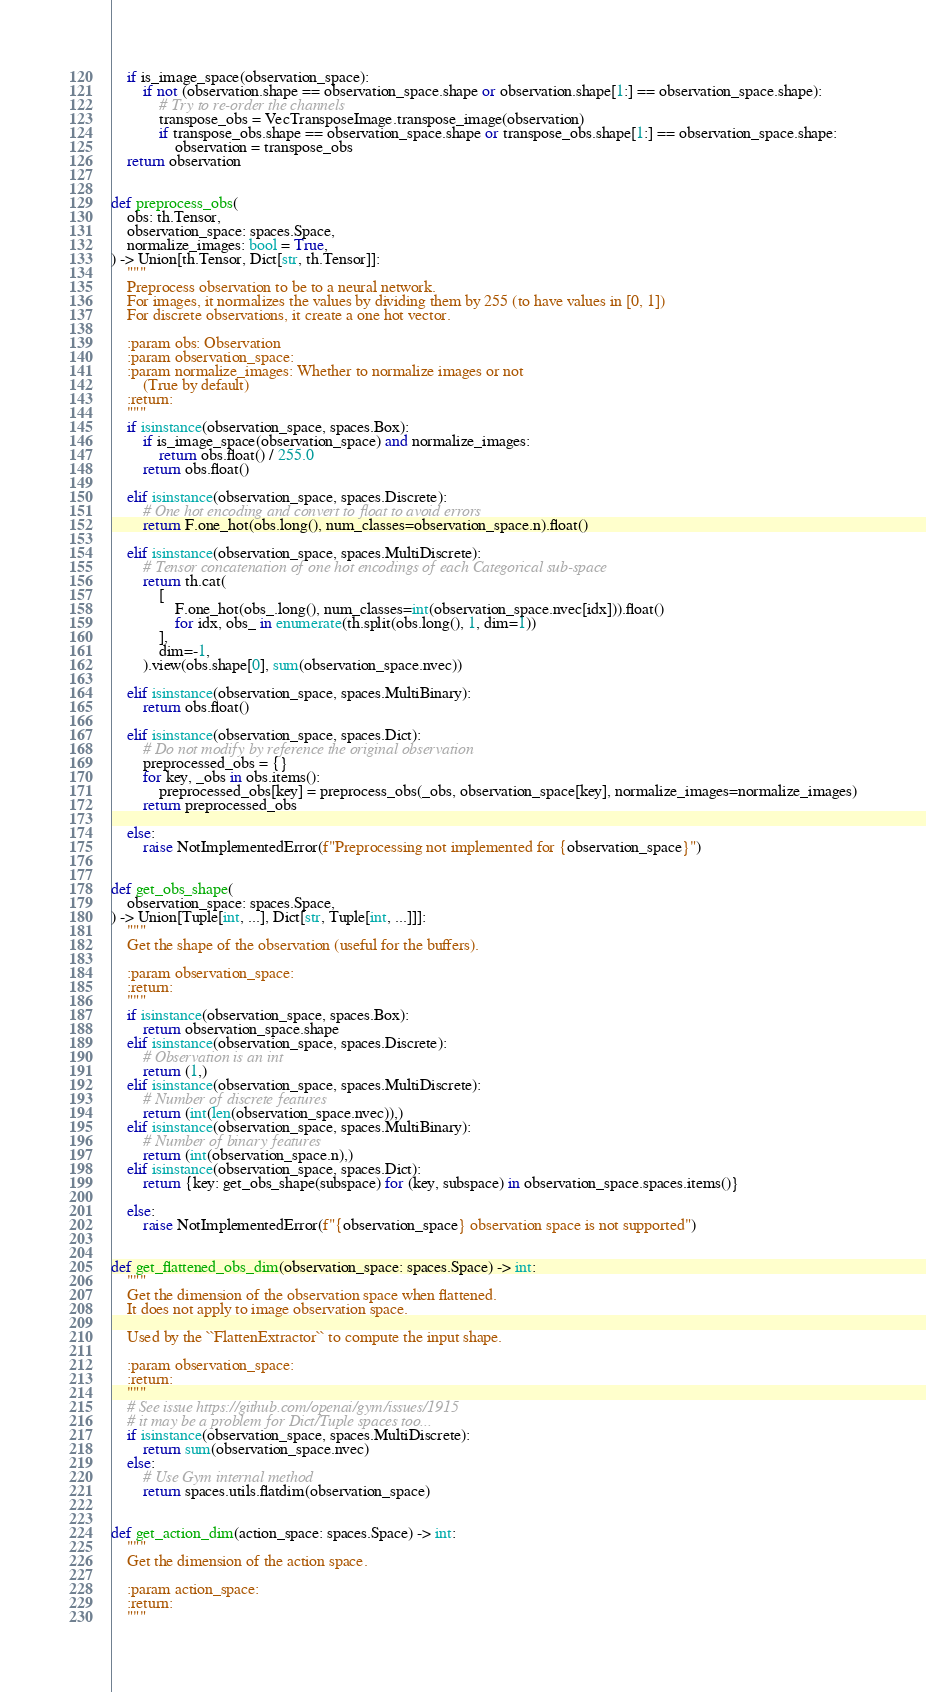Convert code to text. <code><loc_0><loc_0><loc_500><loc_500><_Python_>    if is_image_space(observation_space):
        if not (observation.shape == observation_space.shape or observation.shape[1:] == observation_space.shape):
            # Try to re-order the channels
            transpose_obs = VecTransposeImage.transpose_image(observation)
            if transpose_obs.shape == observation_space.shape or transpose_obs.shape[1:] == observation_space.shape:
                observation = transpose_obs
    return observation


def preprocess_obs(
    obs: th.Tensor,
    observation_space: spaces.Space,
    normalize_images: bool = True,
) -> Union[th.Tensor, Dict[str, th.Tensor]]:
    """
    Preprocess observation to be to a neural network.
    For images, it normalizes the values by dividing them by 255 (to have values in [0, 1])
    For discrete observations, it create a one hot vector.

    :param obs: Observation
    :param observation_space:
    :param normalize_images: Whether to normalize images or not
        (True by default)
    :return:
    """
    if isinstance(observation_space, spaces.Box):
        if is_image_space(observation_space) and normalize_images:
            return obs.float() / 255.0
        return obs.float()

    elif isinstance(observation_space, spaces.Discrete):
        # One hot encoding and convert to float to avoid errors
        return F.one_hot(obs.long(), num_classes=observation_space.n).float()

    elif isinstance(observation_space, spaces.MultiDiscrete):
        # Tensor concatenation of one hot encodings of each Categorical sub-space
        return th.cat(
            [
                F.one_hot(obs_.long(), num_classes=int(observation_space.nvec[idx])).float()
                for idx, obs_ in enumerate(th.split(obs.long(), 1, dim=1))
            ],
            dim=-1,
        ).view(obs.shape[0], sum(observation_space.nvec))

    elif isinstance(observation_space, spaces.MultiBinary):
        return obs.float()

    elif isinstance(observation_space, spaces.Dict):
        # Do not modify by reference the original observation
        preprocessed_obs = {}
        for key, _obs in obs.items():
            preprocessed_obs[key] = preprocess_obs(_obs, observation_space[key], normalize_images=normalize_images)
        return preprocessed_obs

    else:
        raise NotImplementedError(f"Preprocessing not implemented for {observation_space}")


def get_obs_shape(
    observation_space: spaces.Space,
) -> Union[Tuple[int, ...], Dict[str, Tuple[int, ...]]]:
    """
    Get the shape of the observation (useful for the buffers).

    :param observation_space:
    :return:
    """
    if isinstance(observation_space, spaces.Box):
        return observation_space.shape
    elif isinstance(observation_space, spaces.Discrete):
        # Observation is an int
        return (1,)
    elif isinstance(observation_space, spaces.MultiDiscrete):
        # Number of discrete features
        return (int(len(observation_space.nvec)),)
    elif isinstance(observation_space, spaces.MultiBinary):
        # Number of binary features
        return (int(observation_space.n),)
    elif isinstance(observation_space, spaces.Dict):
        return {key: get_obs_shape(subspace) for (key, subspace) in observation_space.spaces.items()}

    else:
        raise NotImplementedError(f"{observation_space} observation space is not supported")


def get_flattened_obs_dim(observation_space: spaces.Space) -> int:
    """
    Get the dimension of the observation space when flattened.
    It does not apply to image observation space.

    Used by the ``FlattenExtractor`` to compute the input shape.

    :param observation_space:
    :return:
    """
    # See issue https://github.com/openai/gym/issues/1915
    # it may be a problem for Dict/Tuple spaces too...
    if isinstance(observation_space, spaces.MultiDiscrete):
        return sum(observation_space.nvec)
    else:
        # Use Gym internal method
        return spaces.utils.flatdim(observation_space)


def get_action_dim(action_space: spaces.Space) -> int:
    """
    Get the dimension of the action space.

    :param action_space:
    :return:
    """</code> 